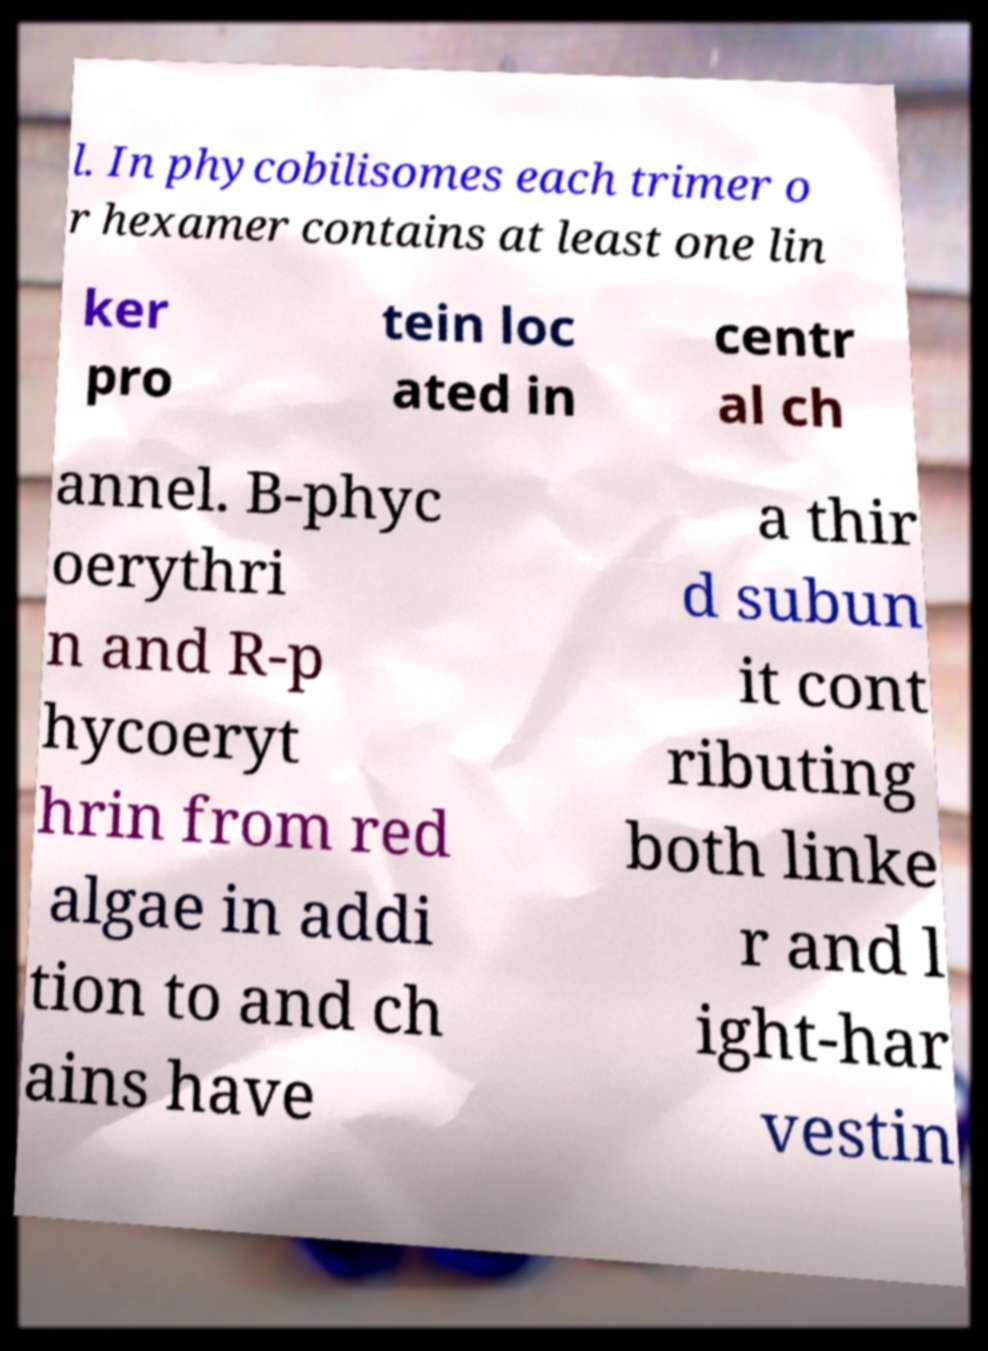Could you extract and type out the text from this image? l. In phycobilisomes each trimer o r hexamer contains at least one lin ker pro tein loc ated in centr al ch annel. B-phyc oerythri n and R-p hycoeryt hrin from red algae in addi tion to and ch ains have a thir d subun it cont ributing both linke r and l ight-har vestin 